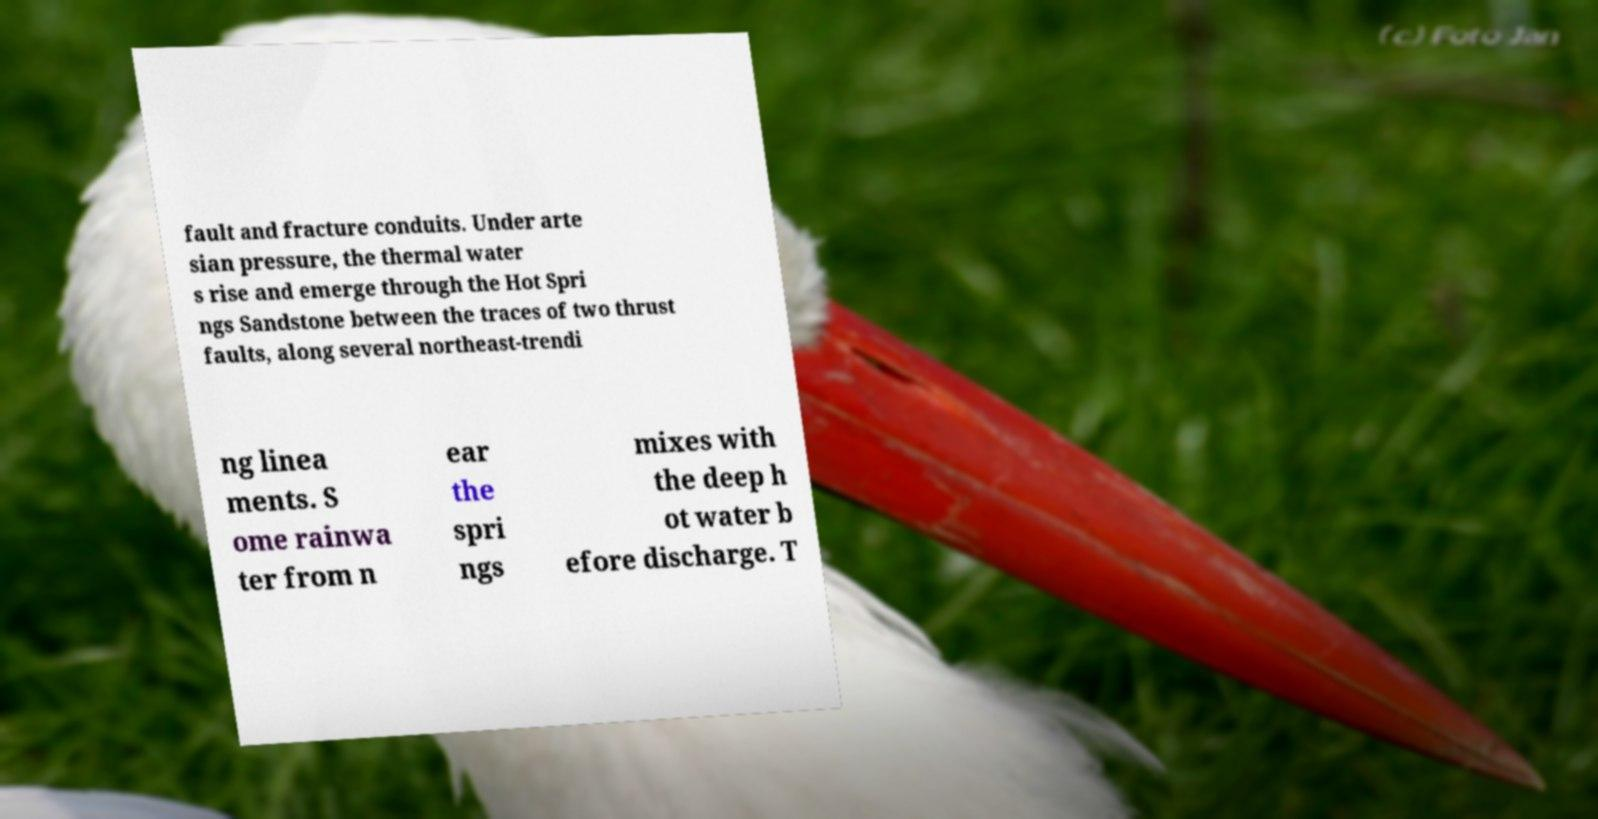There's text embedded in this image that I need extracted. Can you transcribe it verbatim? fault and fracture conduits. Under arte sian pressure, the thermal water s rise and emerge through the Hot Spri ngs Sandstone between the traces of two thrust faults, along several northeast-trendi ng linea ments. S ome rainwa ter from n ear the spri ngs mixes with the deep h ot water b efore discharge. T 